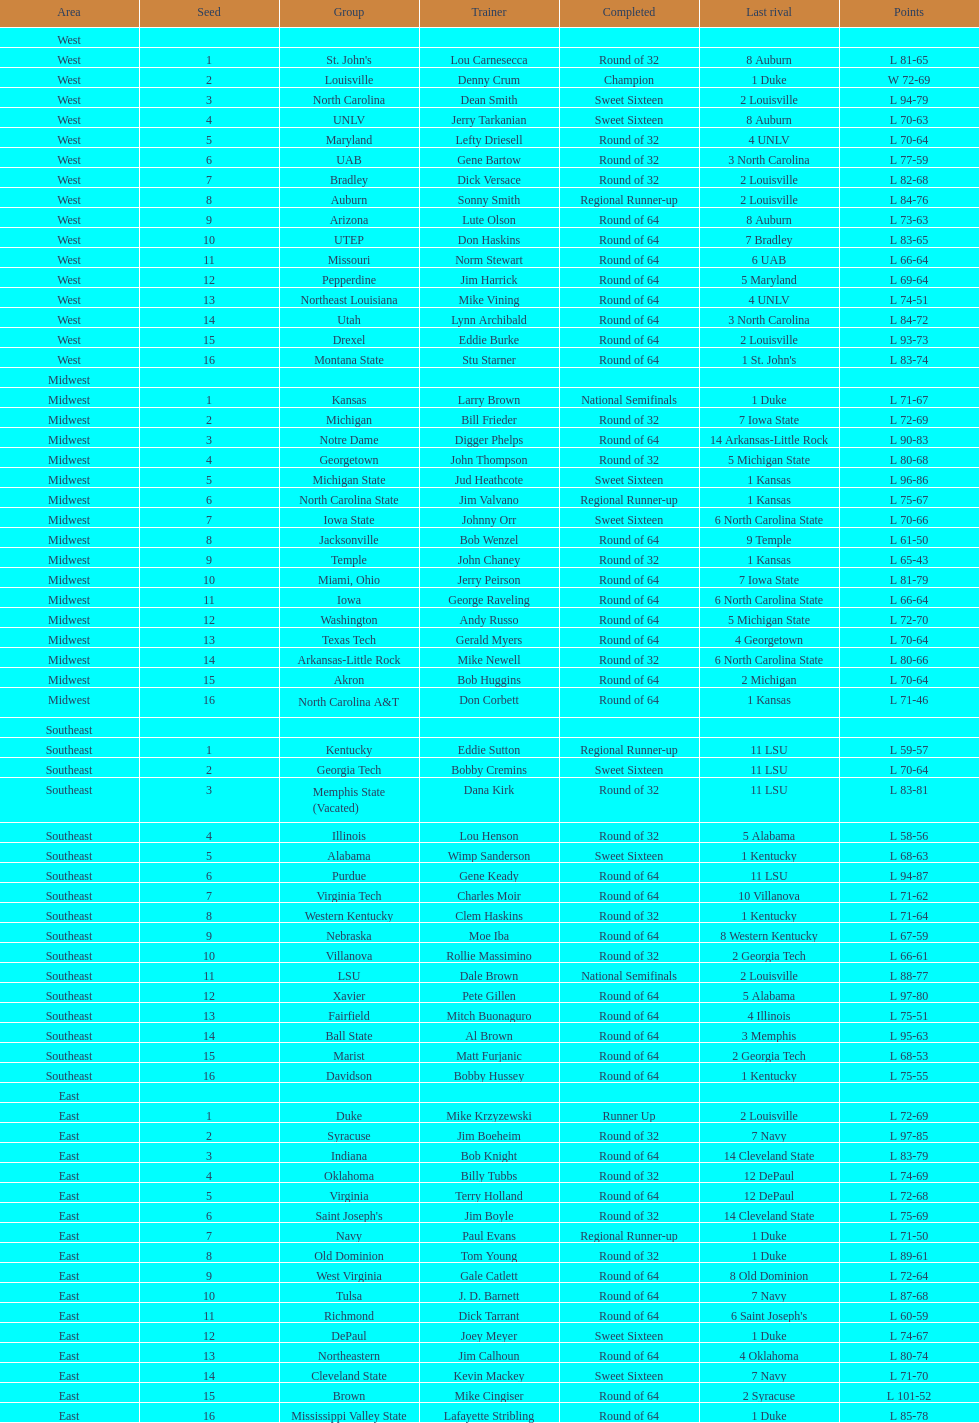What region is listed before the midwest? West. 